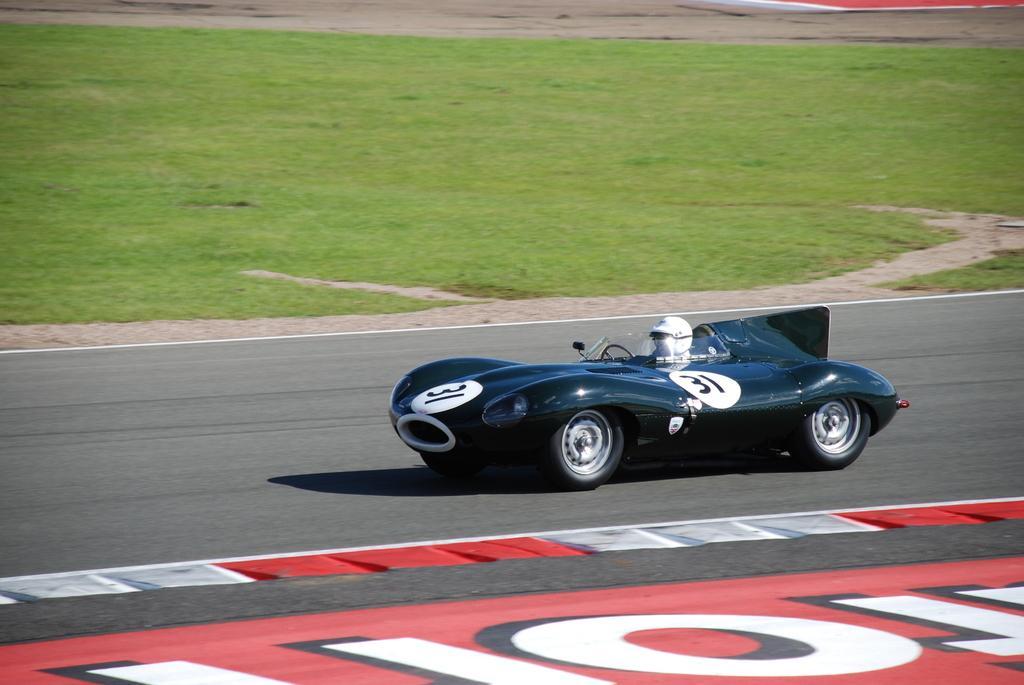Describe this image in one or two sentences. This is a racing car. inside this car a human is sitting. He wore helmet. Beside this car there is a grass. This car is travelling on a road. 